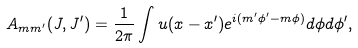<formula> <loc_0><loc_0><loc_500><loc_500>A _ { m m ^ { \prime } } ( J , J ^ { \prime } ) = \frac { 1 } { 2 \pi } \int u ( x - x ^ { \prime } ) e ^ { i ( m ^ { \prime } \phi ^ { \prime } - m \phi ) } d \phi d \phi ^ { \prime } ,</formula> 